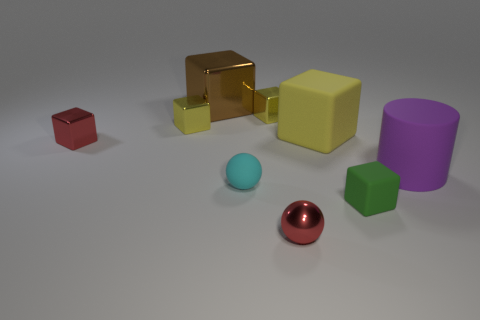What number of things have the same material as the big yellow block?
Provide a succinct answer. 3. Is the large brown cube made of the same material as the large object in front of the tiny red metal cube?
Make the answer very short. No. How many things are things to the left of the large rubber block or green matte blocks?
Offer a very short reply. 7. What size is the red metallic object behind the shiny thing that is in front of the cube on the right side of the big yellow matte thing?
Offer a very short reply. Small. Is there any other thing that is the same shape as the purple thing?
Provide a succinct answer. No. There is a yellow metal object that is left of the tiny yellow cube that is to the right of the brown object; how big is it?
Give a very brief answer. Small. What number of large objects are yellow rubber cylinders or green objects?
Make the answer very short. 0. Are there fewer small metallic things than spheres?
Ensure brevity in your answer.  No. Are there more small brown shiny objects than red metal blocks?
Your answer should be very brief. No. How many other things are there of the same color as the metallic ball?
Make the answer very short. 1. 